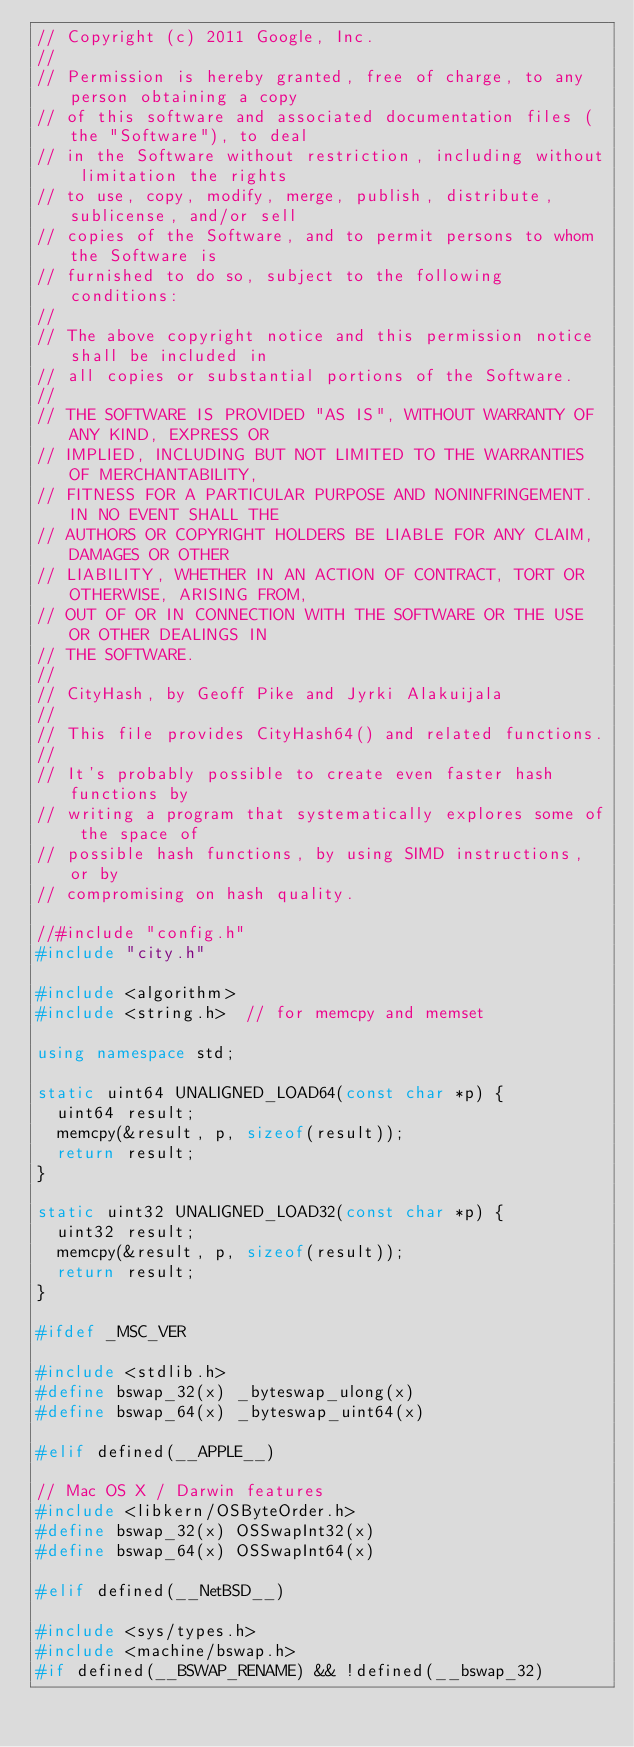<code> <loc_0><loc_0><loc_500><loc_500><_C++_>// Copyright (c) 2011 Google, Inc.
//
// Permission is hereby granted, free of charge, to any person obtaining a copy
// of this software and associated documentation files (the "Software"), to deal
// in the Software without restriction, including without limitation the rights
// to use, copy, modify, merge, publish, distribute, sublicense, and/or sell
// copies of the Software, and to permit persons to whom the Software is
// furnished to do so, subject to the following conditions:
//
// The above copyright notice and this permission notice shall be included in
// all copies or substantial portions of the Software.
//
// THE SOFTWARE IS PROVIDED "AS IS", WITHOUT WARRANTY OF ANY KIND, EXPRESS OR
// IMPLIED, INCLUDING BUT NOT LIMITED TO THE WARRANTIES OF MERCHANTABILITY,
// FITNESS FOR A PARTICULAR PURPOSE AND NONINFRINGEMENT. IN NO EVENT SHALL THE
// AUTHORS OR COPYRIGHT HOLDERS BE LIABLE FOR ANY CLAIM, DAMAGES OR OTHER
// LIABILITY, WHETHER IN AN ACTION OF CONTRACT, TORT OR OTHERWISE, ARISING FROM,
// OUT OF OR IN CONNECTION WITH THE SOFTWARE OR THE USE OR OTHER DEALINGS IN
// THE SOFTWARE.
//
// CityHash, by Geoff Pike and Jyrki Alakuijala
//
// This file provides CityHash64() and related functions.
//
// It's probably possible to create even faster hash functions by
// writing a program that systematically explores some of the space of
// possible hash functions, by using SIMD instructions, or by
// compromising on hash quality.

//#include "config.h"
#include "city.h"

#include <algorithm>
#include <string.h>  // for memcpy and memset

using namespace std;

static uint64 UNALIGNED_LOAD64(const char *p) {
  uint64 result;
  memcpy(&result, p, sizeof(result));
  return result;
}

static uint32 UNALIGNED_LOAD32(const char *p) {
  uint32 result;
  memcpy(&result, p, sizeof(result));
  return result;
}

#ifdef _MSC_VER

#include <stdlib.h>
#define bswap_32(x) _byteswap_ulong(x)
#define bswap_64(x) _byteswap_uint64(x)

#elif defined(__APPLE__)

// Mac OS X / Darwin features
#include <libkern/OSByteOrder.h>
#define bswap_32(x) OSSwapInt32(x)
#define bswap_64(x) OSSwapInt64(x)

#elif defined(__NetBSD__)

#include <sys/types.h>
#include <machine/bswap.h>
#if defined(__BSWAP_RENAME) && !defined(__bswap_32)</code> 